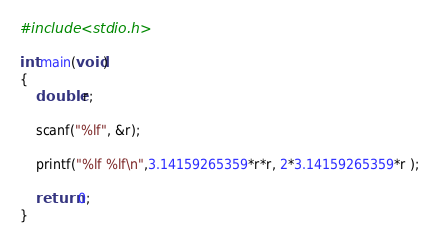<code> <loc_0><loc_0><loc_500><loc_500><_C_>#include <stdio.h>

int main(void)
{
	double r;
	
	scanf("%lf", &r);
	
	printf("%lf %lf\n",3.14159265359*r*r, 2*3.14159265359*r );
	
	return 0;
}</code> 